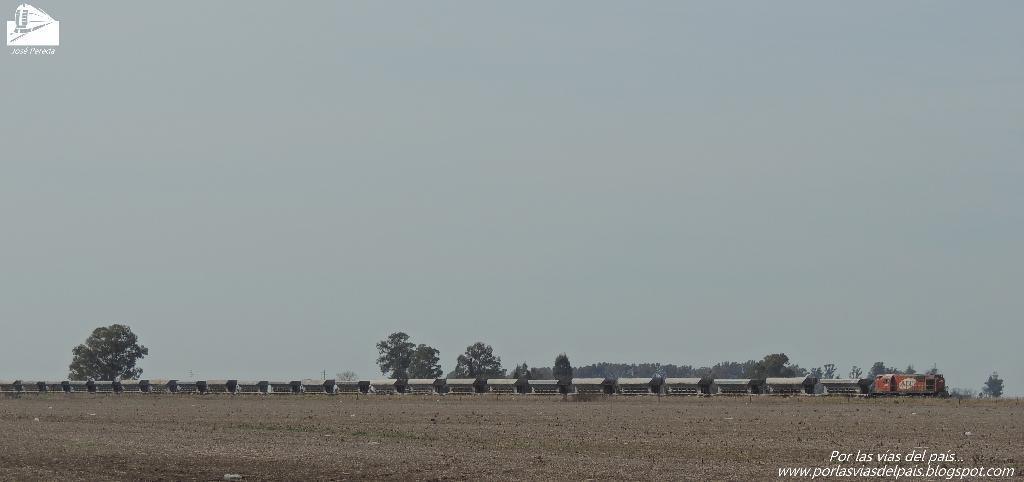How would you summarize this image in a sentence or two? In this image, we can see a train and some trees. At the bottom, there is ground. 